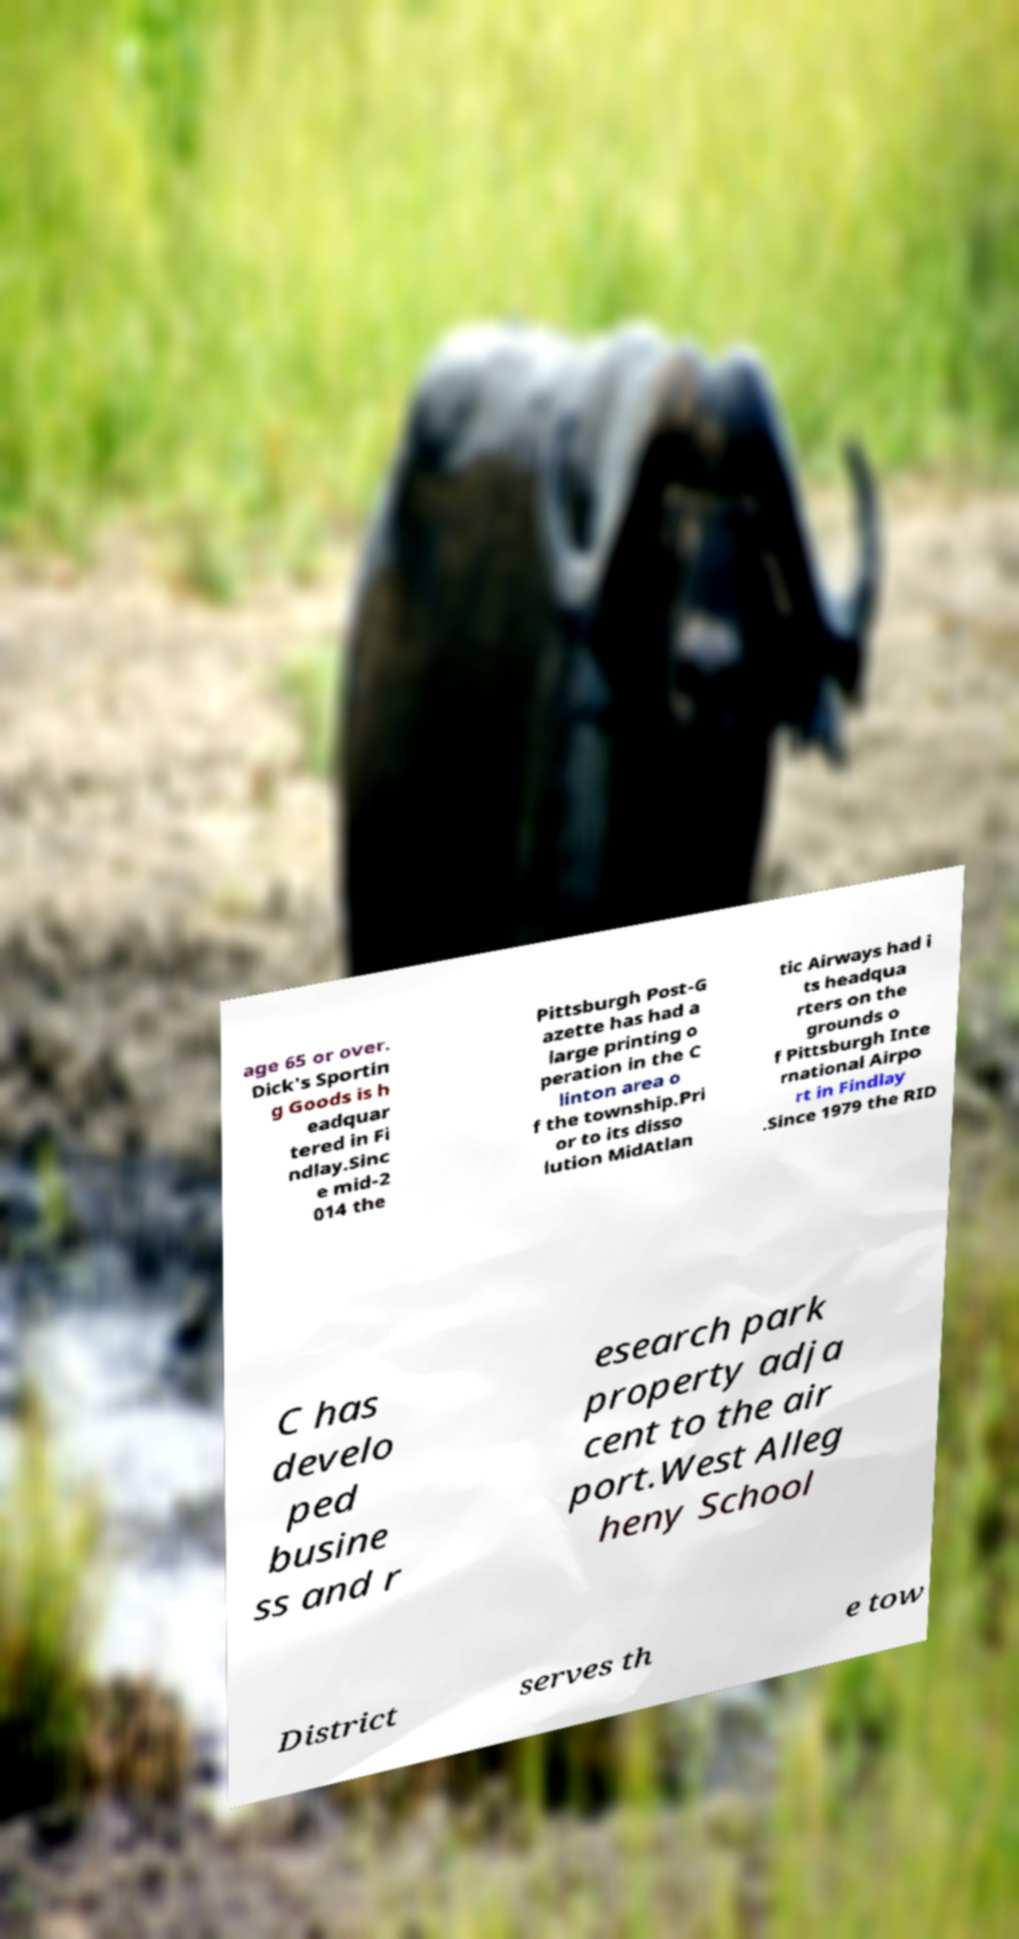I need the written content from this picture converted into text. Can you do that? age 65 or over. Dick's Sportin g Goods is h eadquar tered in Fi ndlay.Sinc e mid-2 014 the Pittsburgh Post-G azette has had a large printing o peration in the C linton area o f the township.Pri or to its disso lution MidAtlan tic Airways had i ts headqua rters on the grounds o f Pittsburgh Inte rnational Airpo rt in Findlay .Since 1979 the RID C has develo ped busine ss and r esearch park property adja cent to the air port.West Alleg heny School District serves th e tow 